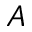<formula> <loc_0><loc_0><loc_500><loc_500>A</formula> 